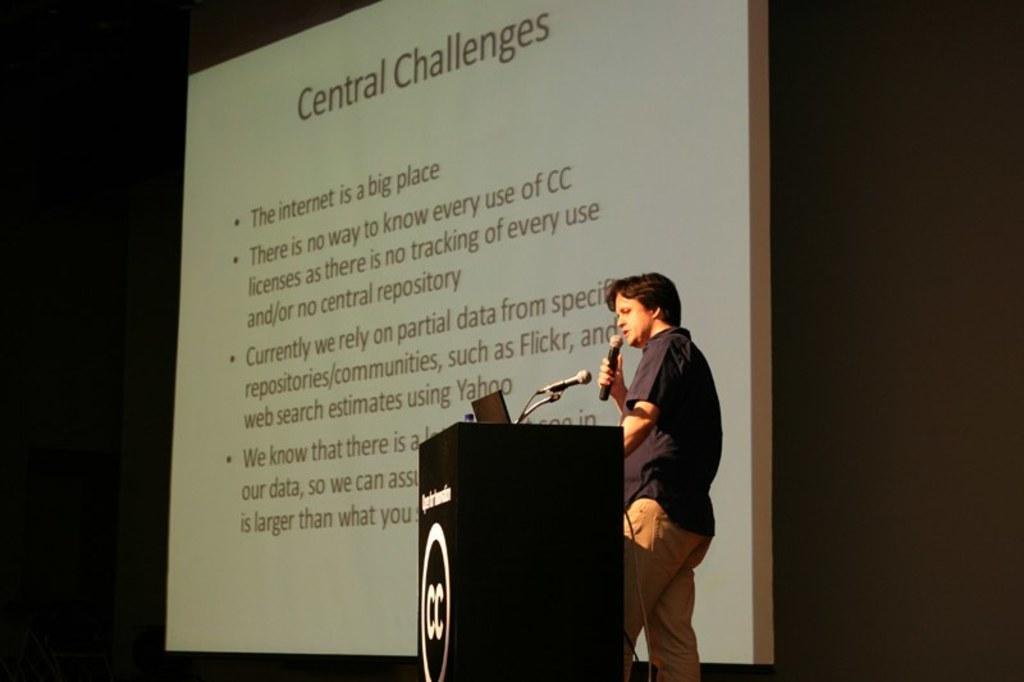Could you give a brief overview of what you see in this image? In this image we can see one podium, one projector screen with text, one laptop, one microphone with wire attached to the podium, one object on the podium, two wires and the background is dark. One man standing, holding a microphone and talking. 